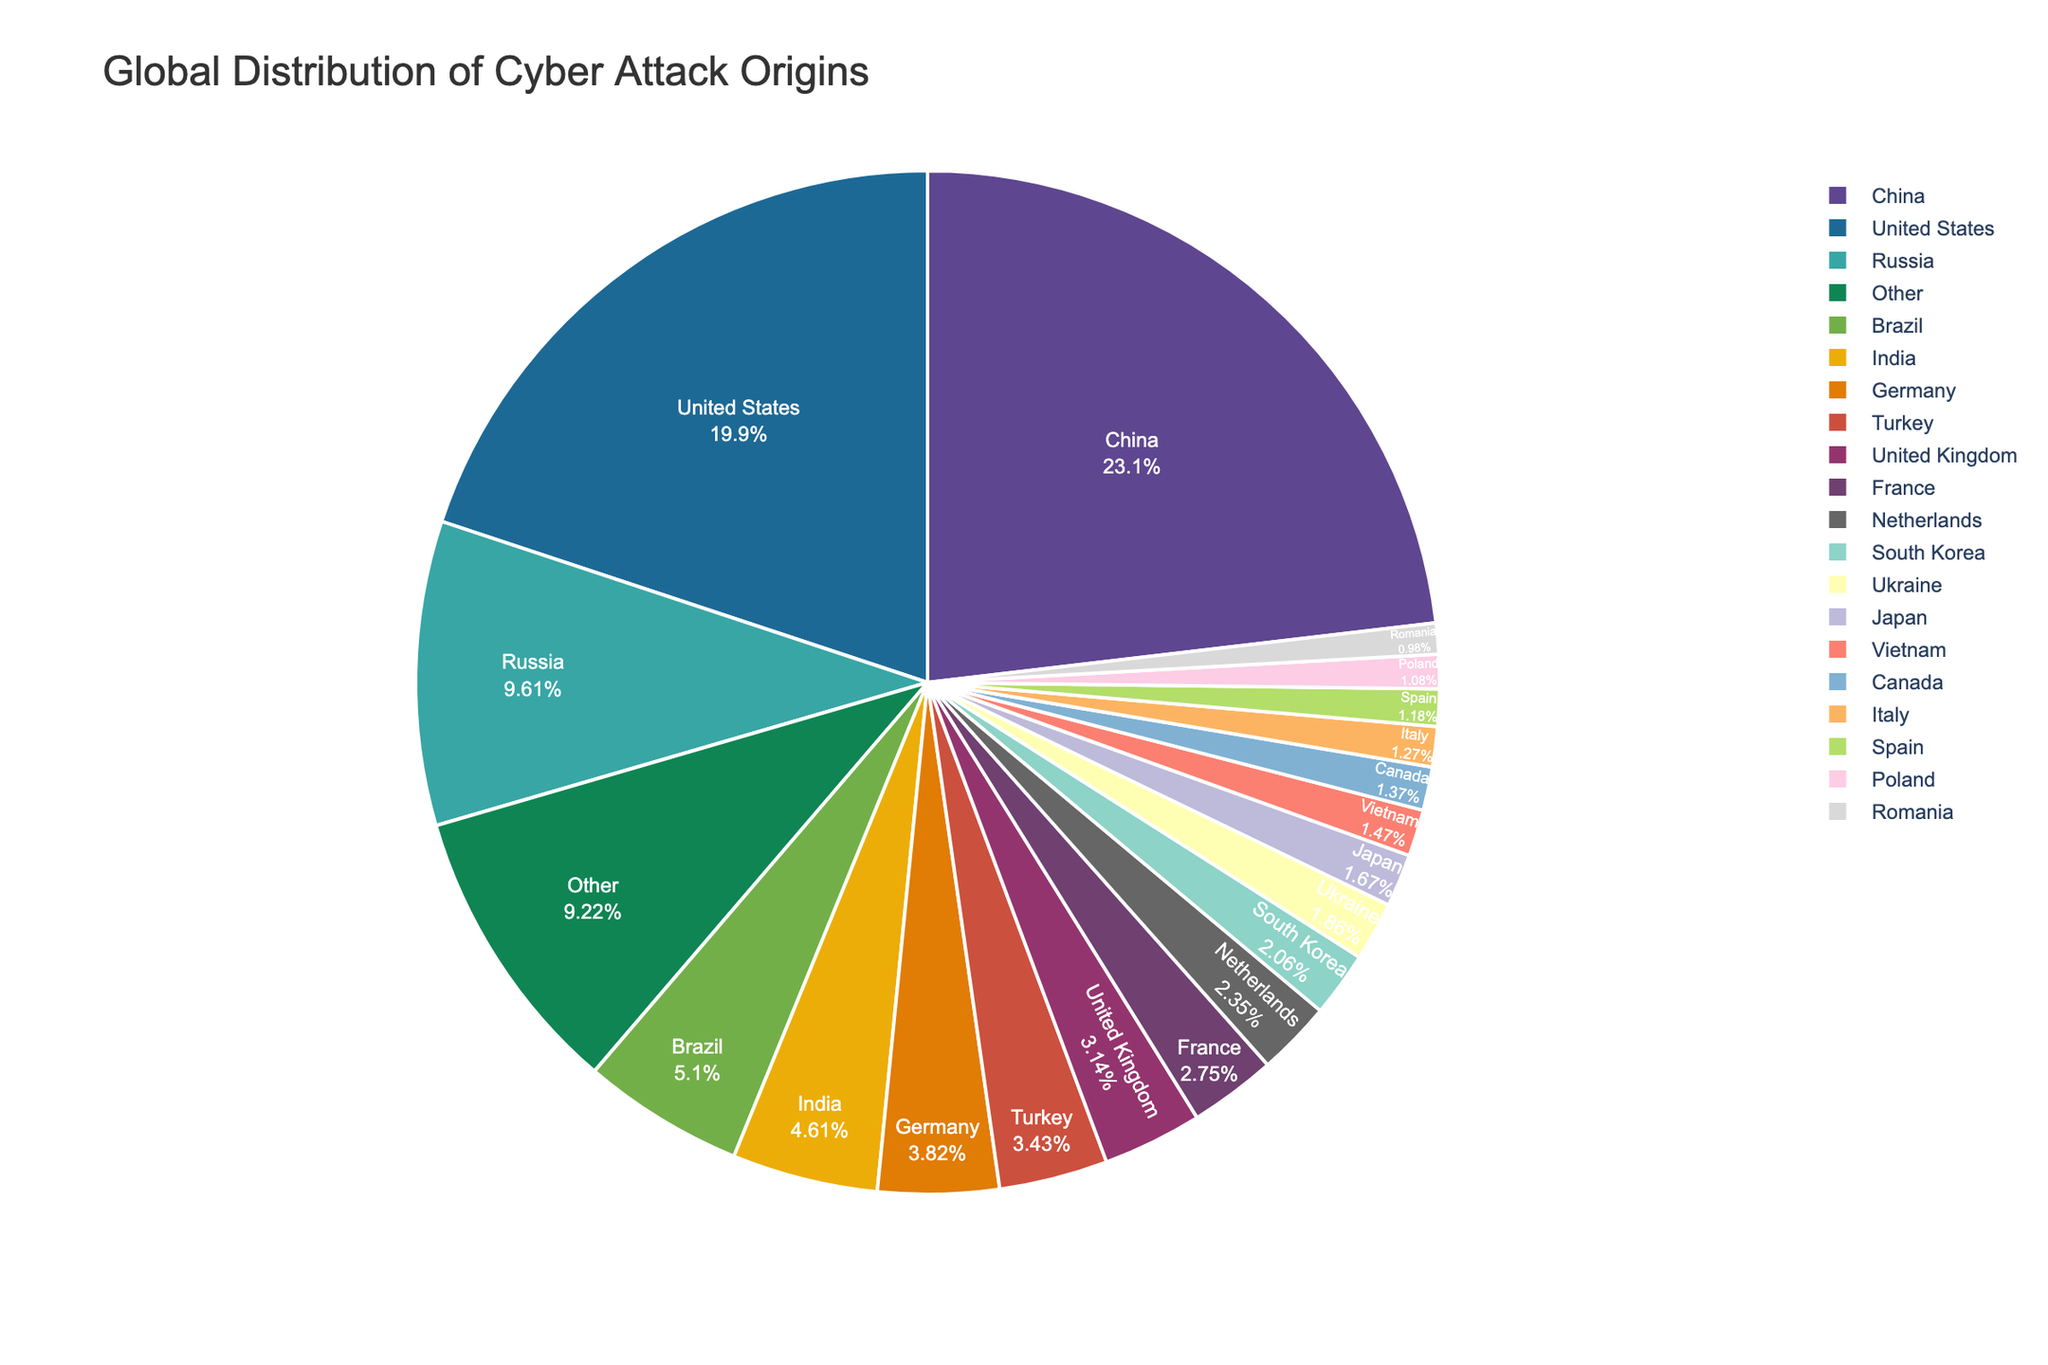question explanation
Answer: concise answer Which country is responsible for the largest percentage of cyber attacks? To identify the country responsible for the largest percentage of cyber attacks, look for the slice in the pie chart with the highest percentage value. The slice labeled 'China' is the largest, representing 23.6%.
Answer: China What is the combined percentage of cyber attacks originating from China and the United States? To find the combined percentage, add the percentages for China and the United States. China accounts for 23.6% and the United States accounts for 20.3%. So, \(23.6 + 20.3 = 43.9\).
Answer: 43.9% Which country has a higher percentage of cyber attacks: Russia or Brazil? Compare the slices labeled 'Russia' and 'Brazil'. Russia has a percentage of 9.8%, while Brazil has 5.2%. Since 9.8 is greater than 5.2, Russia has a higher percentage of cyber attacks.
Answer: Russia How much greater is the percentage of cyber attacks originating from China compared to Russia? Subtract the percentage of Russia from the percentage of China. China has 23.6% and Russia has 9.8%, so \(23.6 - 9.8 = 13.8\).
Answer: 13.8% Which countries have a percentage of cyber attacks between 2% and 3%? Look for slices in the pie chart with percentages between 2% and 3%. These countries are: France (2.8%), Netherlands (2.4%), and South Korea (2.1%).
Answer: France, Netherlands, South Korea What is the total percentage of cyber attacks originating from Turkey, United Kingdom, and Germany? Add the percentages for Turkey, United Kingdom, and Germany. Turkey has 3.5%, United Kingdom has 3.2%, and Germany has 3.9%. So, \(3.5 + 3.2 + 3.9 = 10.6\).
Answer: 10.6% How does the percentage of cyber attacks from India compare to that from Turkey? Compare the percentage values for India and Turkey. India has a percentage of 4.7%, while Turkey has 3.5%. Since 4.7 is greater than 3.5, India has a higher percentage of cyber attacks.
Answer: India Which countries cumulatively contribute to more than 50% of the total cyber attacks? Start by adding the percentages in descending order until the sum exceeds 50%. China (23.6%), United States (20.3%), and Russia (9.8%) have a cumulative percentage of \(23.6 + 20.3 + 9.8 = 53.7\), which is more than 50%.
Answer: China, United States, Russia How does the percentage of cyber attacks from the 'Other' category compare to the percentages of Brazil and India combined? Add the percentages for Brazil and India to compare with 'Other'. Brazil has 5.2% and India has 4.7%, summing up to \(5.2 + 4.7 = 9.9\). 'Other' category has 9.4%, which is less than 9.9%.
Answer: Less What is the median percentage of cyber attacks from the provided countries (excluding 'Other')? Sort the percentages in ascending order and find the middle value. The sorted percentages are: 1.0, 1.1, 1.2, 1.3, 1.4, 1.5, 1.7, 1.9, 2.1, 2.4, 2.8, 3.2, 3.5, 3.9, 4.7, 5.2, 9.8, 20.3, 23.6. There are 19 values, so the median is the 10th value: 2.4.
Answer: 2.4 